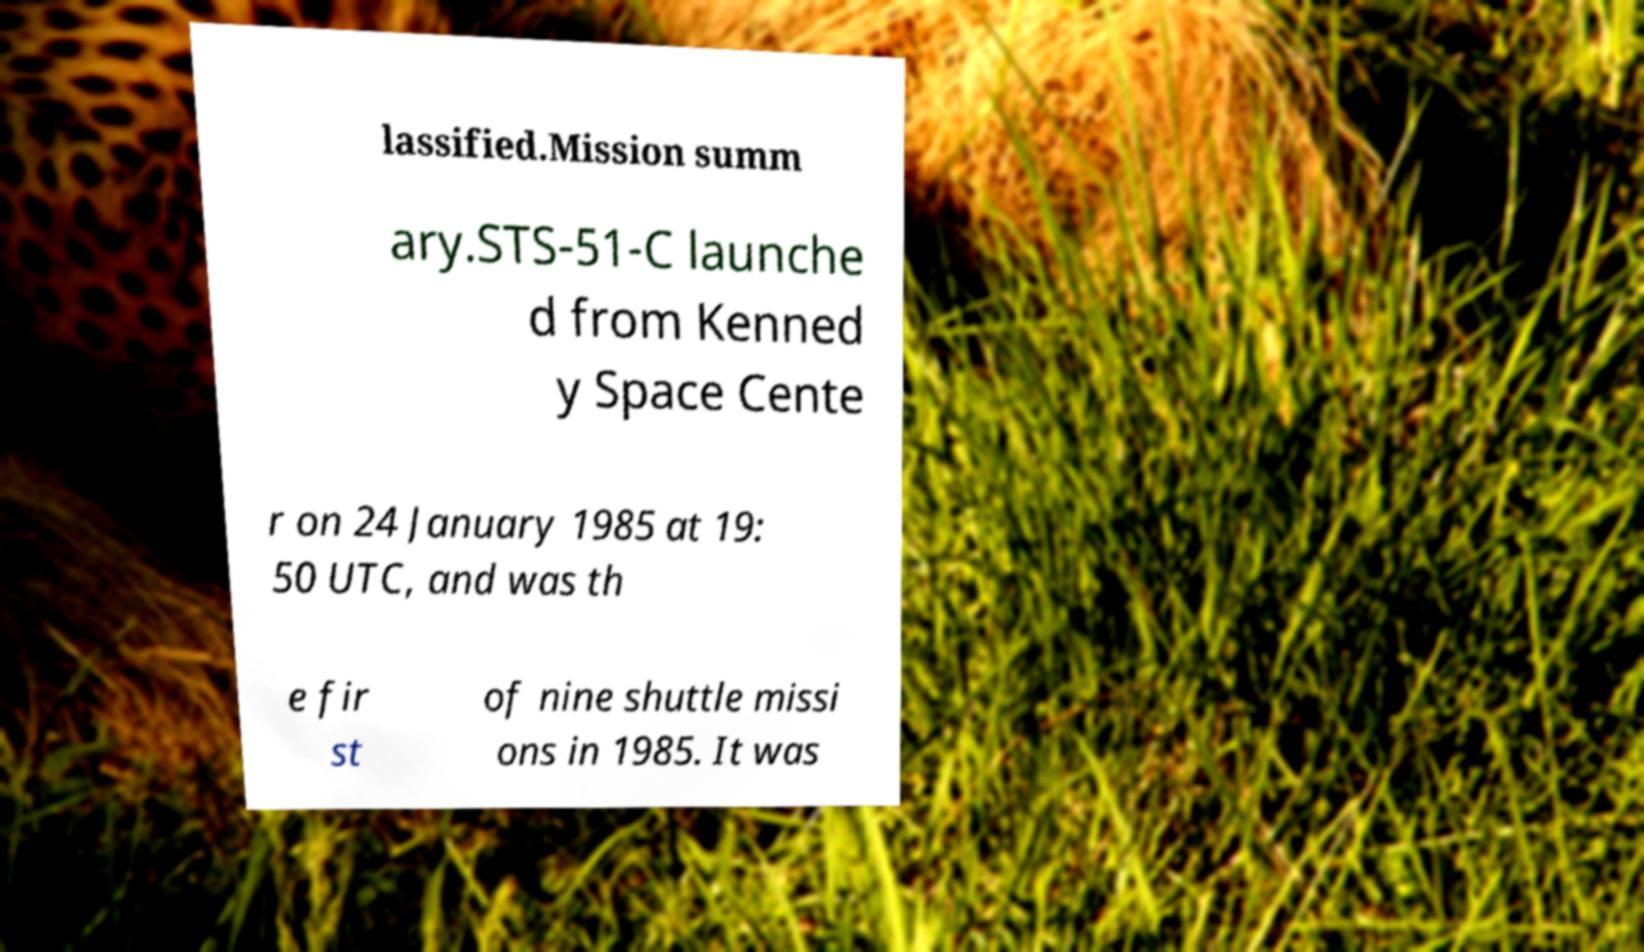Could you extract and type out the text from this image? lassified.Mission summ ary.STS-51-C launche d from Kenned y Space Cente r on 24 January 1985 at 19: 50 UTC, and was th e fir st of nine shuttle missi ons in 1985. It was 